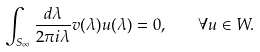<formula> <loc_0><loc_0><loc_500><loc_500>\int _ { S _ { \infty } } \frac { d \lambda } { 2 \pi i \lambda } v ( \lambda ) u ( \lambda ) = 0 , \quad \forall u \in W .</formula> 